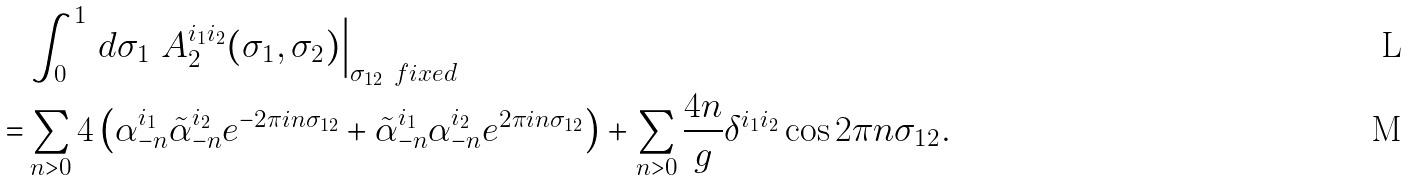<formula> <loc_0><loc_0><loc_500><loc_500>& \int _ { 0 } ^ { 1 } \, d \sigma _ { 1 } \ A _ { 2 } ^ { i _ { 1 } i _ { 2 } } ( \sigma _ { 1 } , \sigma _ { 2 } ) \Big | _ { \sigma _ { 1 2 } \ f i x e d } \\ = & \sum _ { n > 0 } 4 \left ( \alpha _ { - n } ^ { i _ { 1 } } \tilde { \alpha } _ { - n } ^ { i _ { 2 } } e ^ { - 2 \pi i n \sigma _ { 1 2 } } + \tilde { \alpha } _ { - n } ^ { i _ { 1 } } \alpha _ { - n } ^ { i _ { 2 } } e ^ { 2 \pi i n \sigma _ { 1 2 } } \right ) + \sum _ { n > 0 } \frac { 4 n } { g } \delta ^ { i _ { 1 } i _ { 2 } } \cos 2 \pi n \sigma _ { 1 2 } .</formula> 